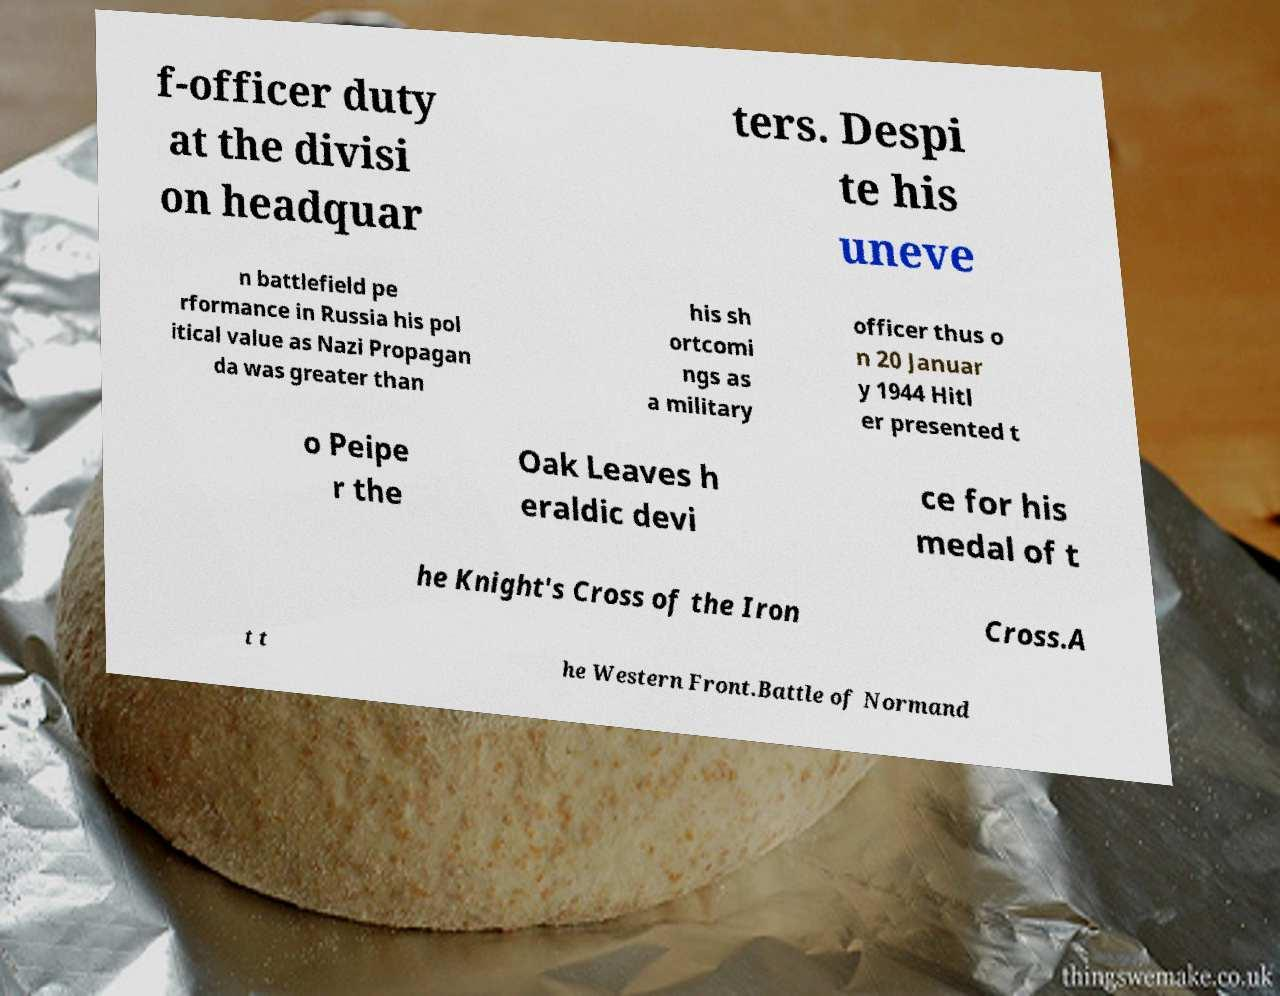For documentation purposes, I need the text within this image transcribed. Could you provide that? f-officer duty at the divisi on headquar ters. Despi te his uneve n battlefield pe rformance in Russia his pol itical value as Nazi Propagan da was greater than his sh ortcomi ngs as a military officer thus o n 20 Januar y 1944 Hitl er presented t o Peipe r the Oak Leaves h eraldic devi ce for his medal of t he Knight's Cross of the Iron Cross.A t t he Western Front.Battle of Normand 